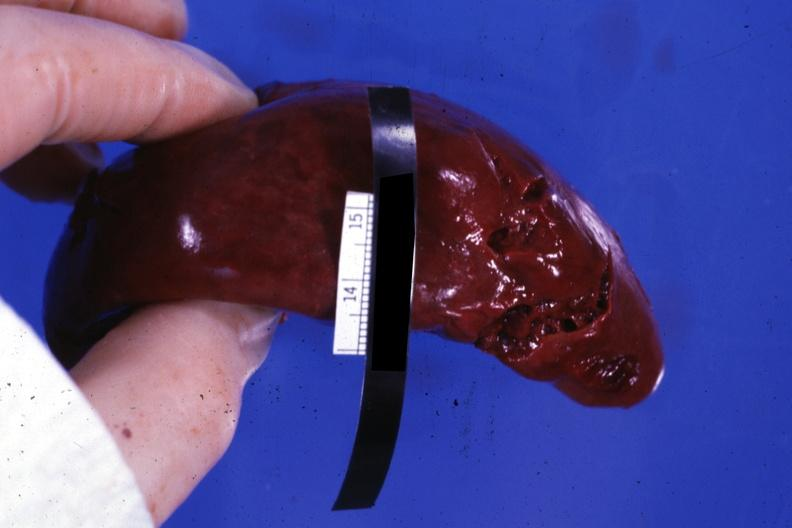where is this part in?
Answer the question using a single word or phrase. Spleen 